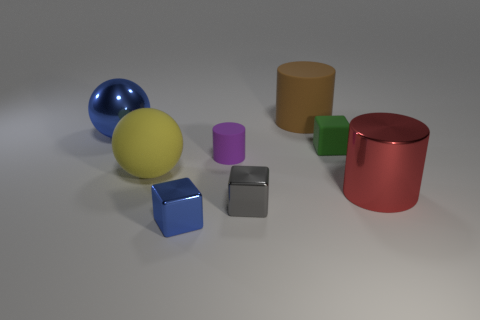Subtract 1 cubes. How many cubes are left? 2 Add 1 cubes. How many objects exist? 9 Subtract all cylinders. How many objects are left? 5 Subtract all big matte cylinders. Subtract all purple matte things. How many objects are left? 6 Add 3 blocks. How many blocks are left? 6 Add 2 tiny cyan matte blocks. How many tiny cyan matte blocks exist? 2 Subtract 1 brown cylinders. How many objects are left? 7 